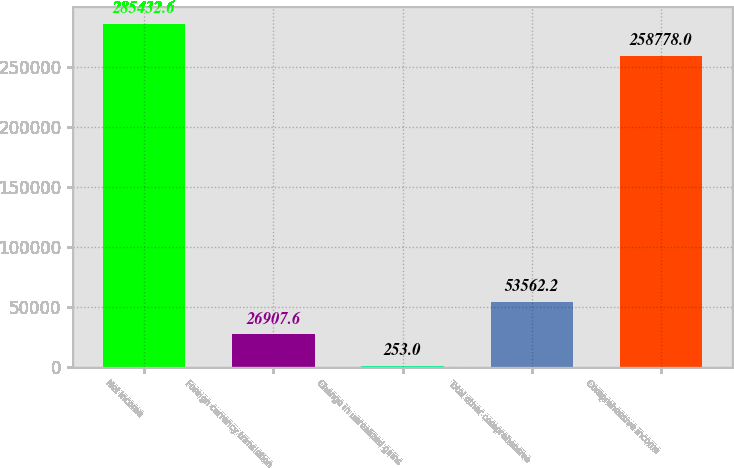<chart> <loc_0><loc_0><loc_500><loc_500><bar_chart><fcel>Net income<fcel>Foreign currency translation<fcel>Change in unrealized gains<fcel>Total other comprehensive<fcel>Comprehensive income<nl><fcel>285433<fcel>26907.6<fcel>253<fcel>53562.2<fcel>258778<nl></chart> 